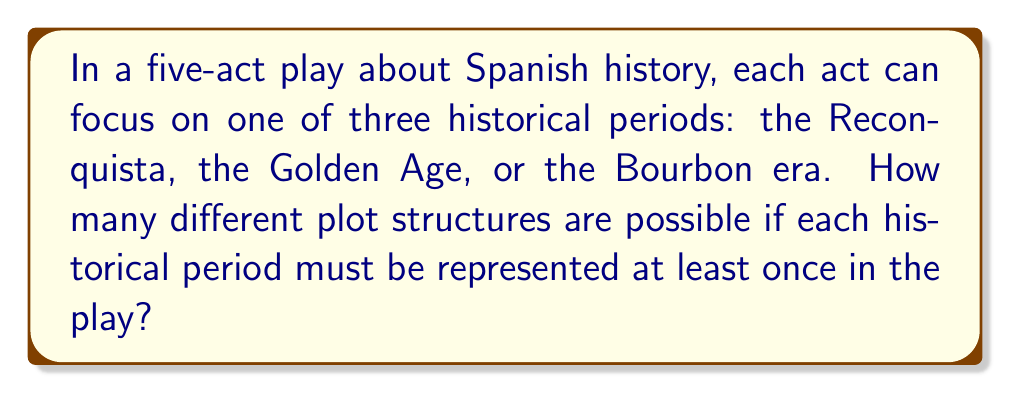Can you answer this question? Let's approach this step-by-step:

1) We have 5 acts and 3 historical periods. Each act must focus on one of these periods, and each period must be represented at least once.

2) This is a case of distributing distinguishable objects (the 5 acts) into distinguishable boxes (the 3 periods) with restrictions.

3) We can use the Inclusion-Exclusion Principle to solve this problem:

   Let A be the total number of ways to distribute 5 acts into 3 periods.
   Let B be the number of ways where at least one period is not represented.

   The answer we want is A - B.

4) To calculate A: This is simply $3^5 = 243$, as each act has 3 choices.

5) To calculate B, we use Inclusion-Exclusion:
   
   B = (ways with at least 1 period missing)
     = (ways with 1st period missing) + (ways with 2nd period missing) + (ways with 3rd period missing)
     - (ways with 1st and 2nd missing) - (ways with 1st and 3rd missing) - (ways with 2nd and 3rd missing)
     + (ways with all three missing)

   = $3 \cdot 2^5 - 3 \cdot 1^5 + 0^5$
   = $3 \cdot 32 - 3 + 0$
   = $96 - 3$
   = $93$

6) Therefore, the number of valid plot structures is:
   
   $A - B = 243 - 93 = 150$
Answer: 150 